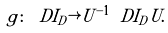<formula> <loc_0><loc_0><loc_500><loc_500>g \colon \ D I _ { D } \rightarrow U ^ { - 1 } \ D I _ { D } U .</formula> 